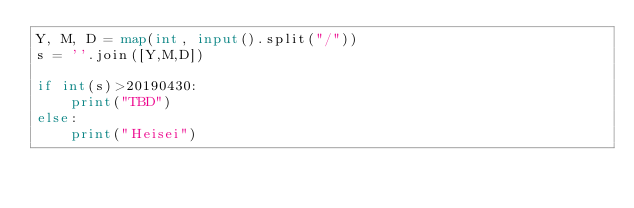Convert code to text. <code><loc_0><loc_0><loc_500><loc_500><_Python_>Y, M, D = map(int, input().split("/"))
s = ''.join([Y,M,D])

if int(s)>20190430:
    print("TBD")
else:
    print("Heisei")
</code> 